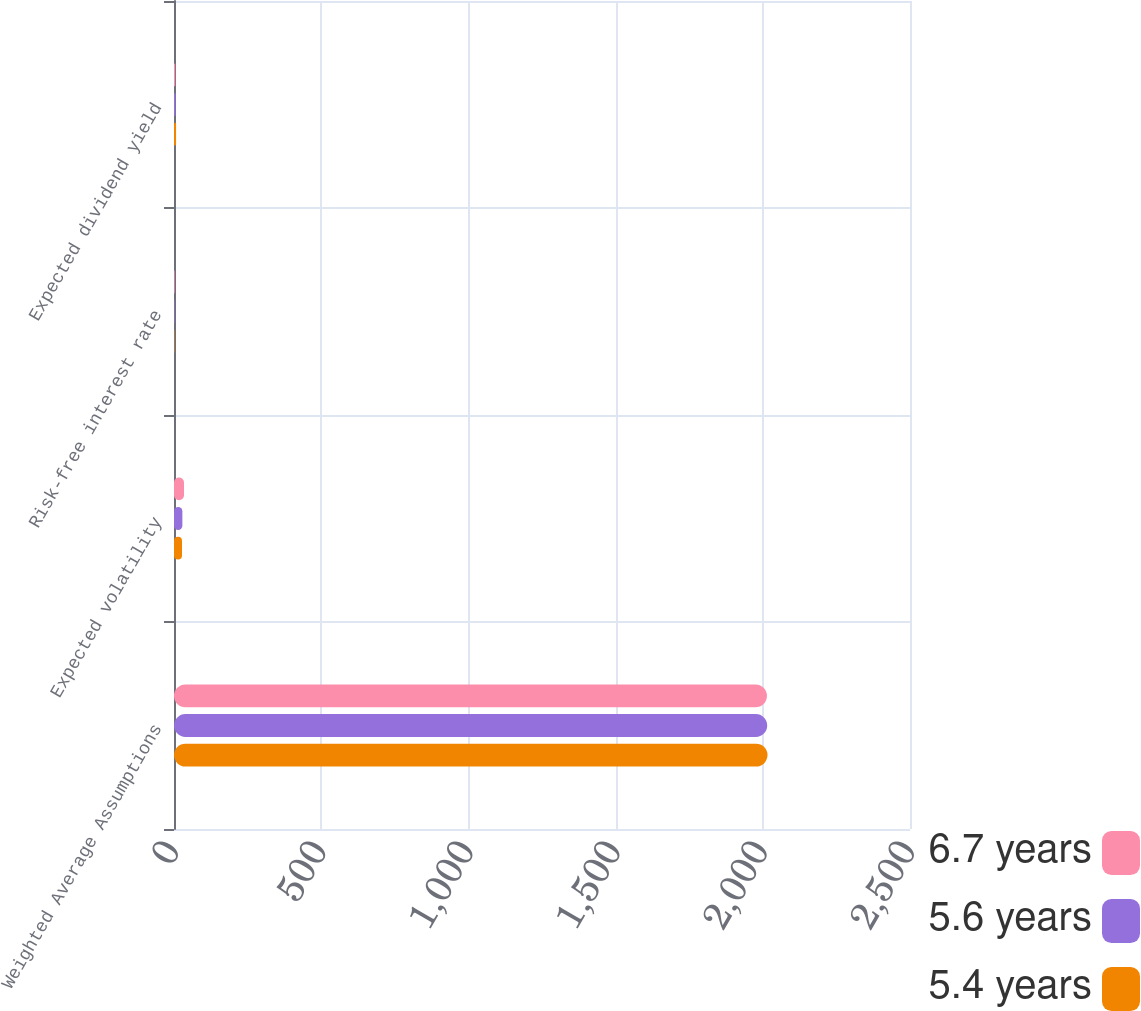Convert chart. <chart><loc_0><loc_0><loc_500><loc_500><stacked_bar_chart><ecel><fcel>Weighted Average Assumptions<fcel>Expected volatility<fcel>Risk-free interest rate<fcel>Expected dividend yield<nl><fcel>6.7 years<fcel>2014<fcel>34<fcel>2.04<fcel>4<nl><fcel>5.6 years<fcel>2015<fcel>28.4<fcel>1.7<fcel>5<nl><fcel>5.4 years<fcel>2016<fcel>27.2<fcel>1.32<fcel>7<nl></chart> 